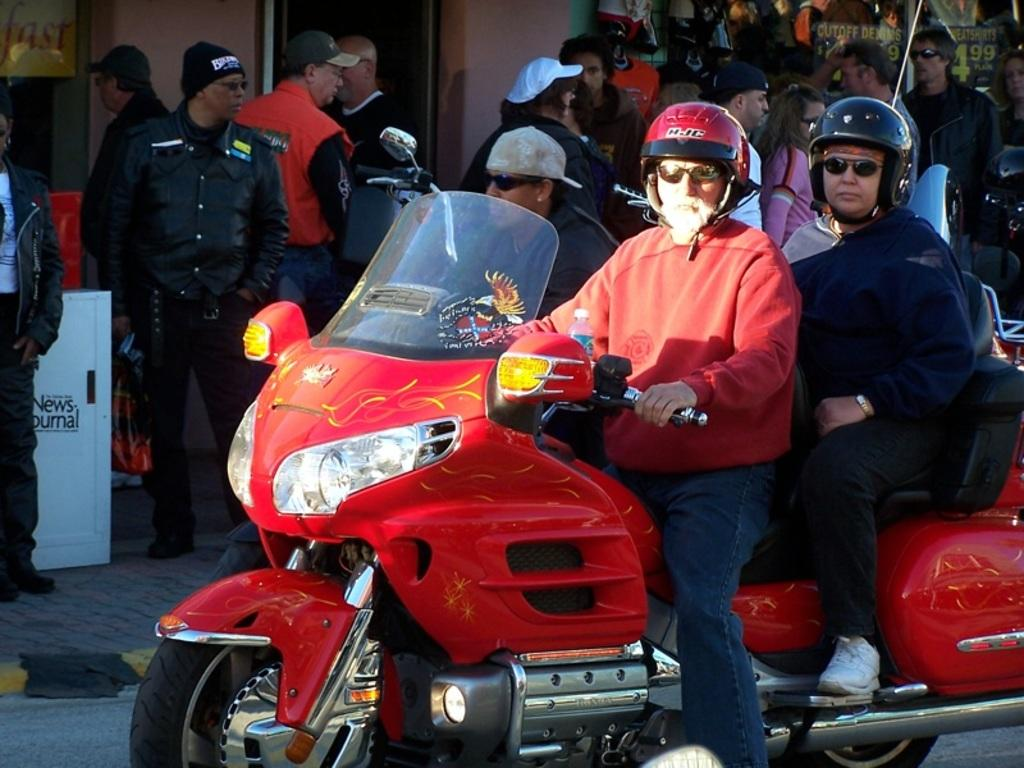How many people are in the image? There are two people in the image. What are the two people doing in the image? The two people are sitting on a motorcycle. What safety precautions are the people taking in the image? Both people are wearing helmets. What can be seen in the background of the image? There is a group of people in the background of the image. What type of chair is the authority sitting on in the image? There is no authority or chair present in the image. 